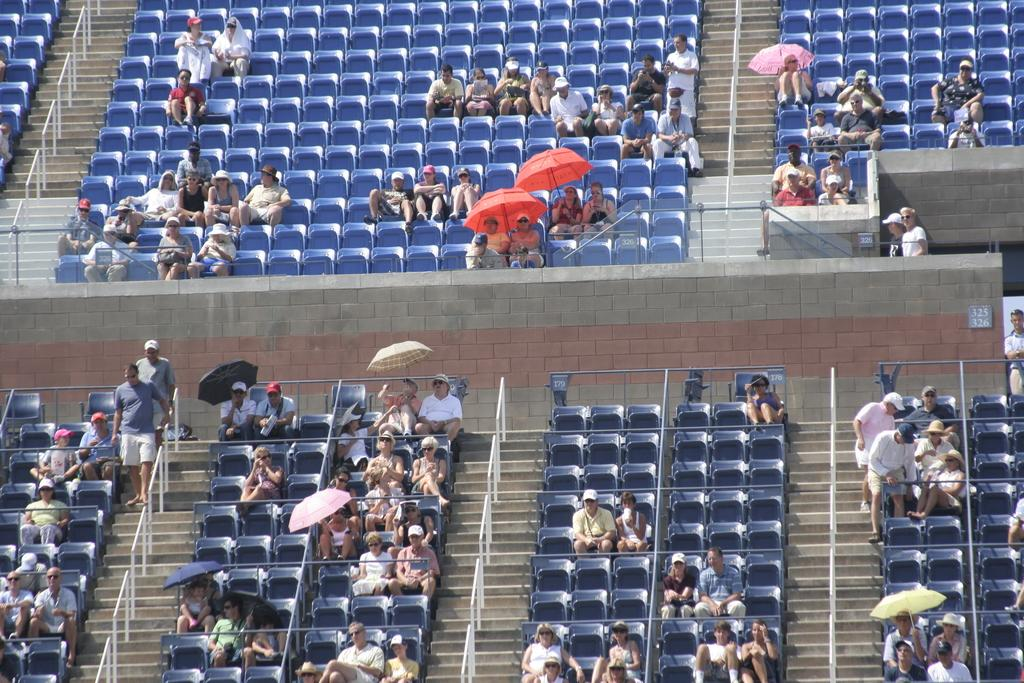What are the people in the image doing? The people in the image are sitting on chairs. What are some people holding in the image? Some people are holding umbrellas in the image. What can be said about the umbrellas in the image? The umbrellas are in different colors. What architectural feature is visible in the image? There are stairs visible in the image. What else can be seen in the image? There are poles in the image. How many family members can be seen in the image? There is no information about family members in the image. 